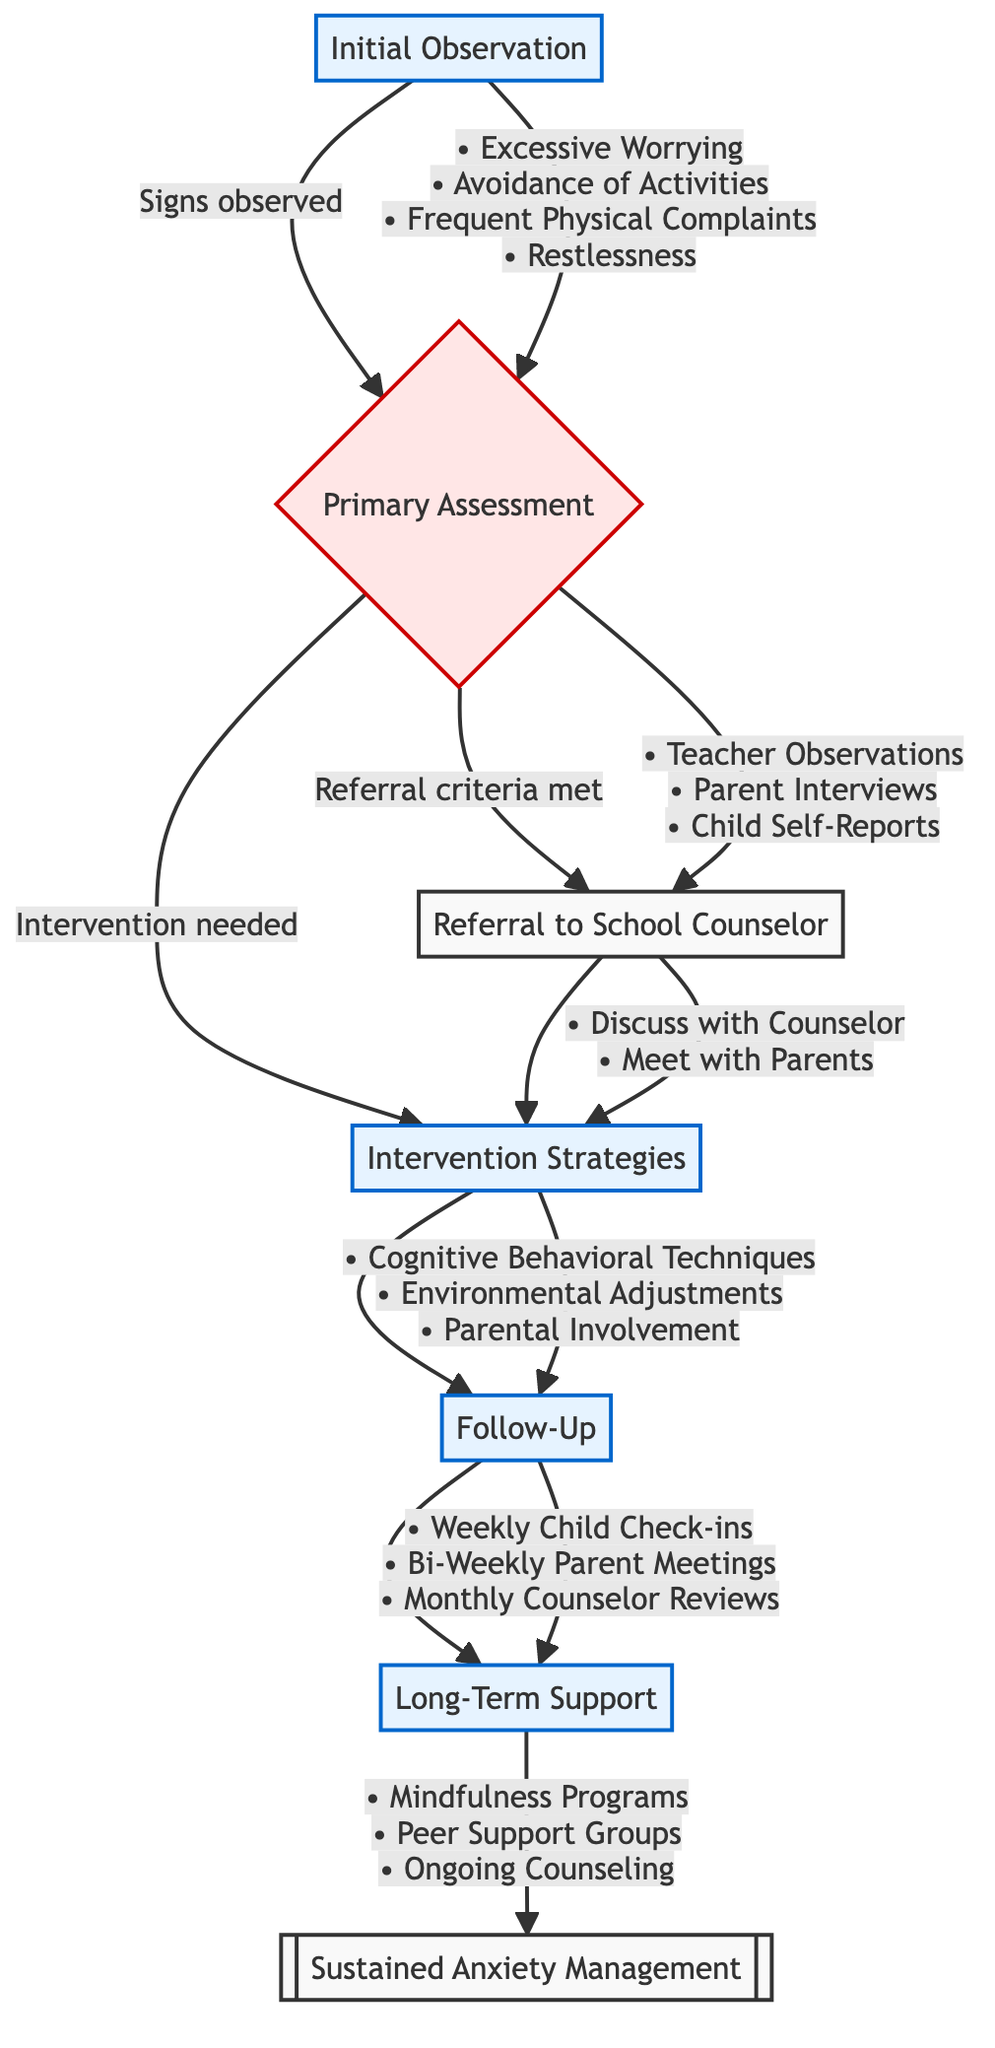What are the signs observed in Initial Observation? The signs are detailed in the diagram under "Initial Observation." They include "Excessive Worrying," "Avoidance of Activities," "Frequent Physical Complaints," and "Restlessness."
Answer: Excessive Worrying, Avoidance of Activities, Frequent Physical Complaints, Restlessness What is the first step after Initial Observation? From the diagram, the flow proceeds from "Initial Observation" to "Primary Assessment" as indicated by the arrow. This shows that "Primary Assessment" is a follow-up step after observations are made.
Answer: Primary Assessment How many tools are listed under Primary Assessment? The diagram states that there are "Teacher Observations," "Parent Interviews," and "Child Self-Reports" as tools. Counting these, we find there are three tools listed.
Answer: 3 What actions are taken after referring to the School Counselor? The diagram indicates that after a referral to the School Counselor, the actions are to "Discuss Observations with Counselor" and "Arrange Meeting with Parents." These actions are listed under the "Referral to School Counselor" section.
Answer: Discuss Observations with Counselor, Arrange Meeting with Parents What is the frequency of the Follow-Up check-ins with the child? The diagram illustrates the Follow-Up step includes "Weekly Check-ins with Child," which specifies how often those check-ins will occur.
Answer: Weekly Check-ins with Child In which two areas are strategies outlined under Intervention Strategies? The diagram shows that "Intervention Strategies" are divided into "Cognitive Behavioral Techniques," "Environmental Adjustments," and "Parental Involvement," meaning the strategies are located within these three areas.
Answer: Cognitive Behavioral Techniques, Environmental Adjustments, Parental Involvement What is the goal of Long-Term Support? The diagram specifies that the goals under "Long-Term Support" include "Sustained Anxiety Management," "Enhanced Coping Skills," and "Promote Overall Well-Being." Thus, the goal can be concisely identified.
Answer: Sustained Anxiety Management What is the relationship between Primary Assessment and Intervention Strategies? Upon checking the diagram, we see that "Primary Assessment" flows to both "Referral to School Counselor" and "Intervention Strategies," indicating that depending on the assessments, strategies may follow directly if needed.
Answer: It leads to both Referral to School Counselor and Intervention Strategies 